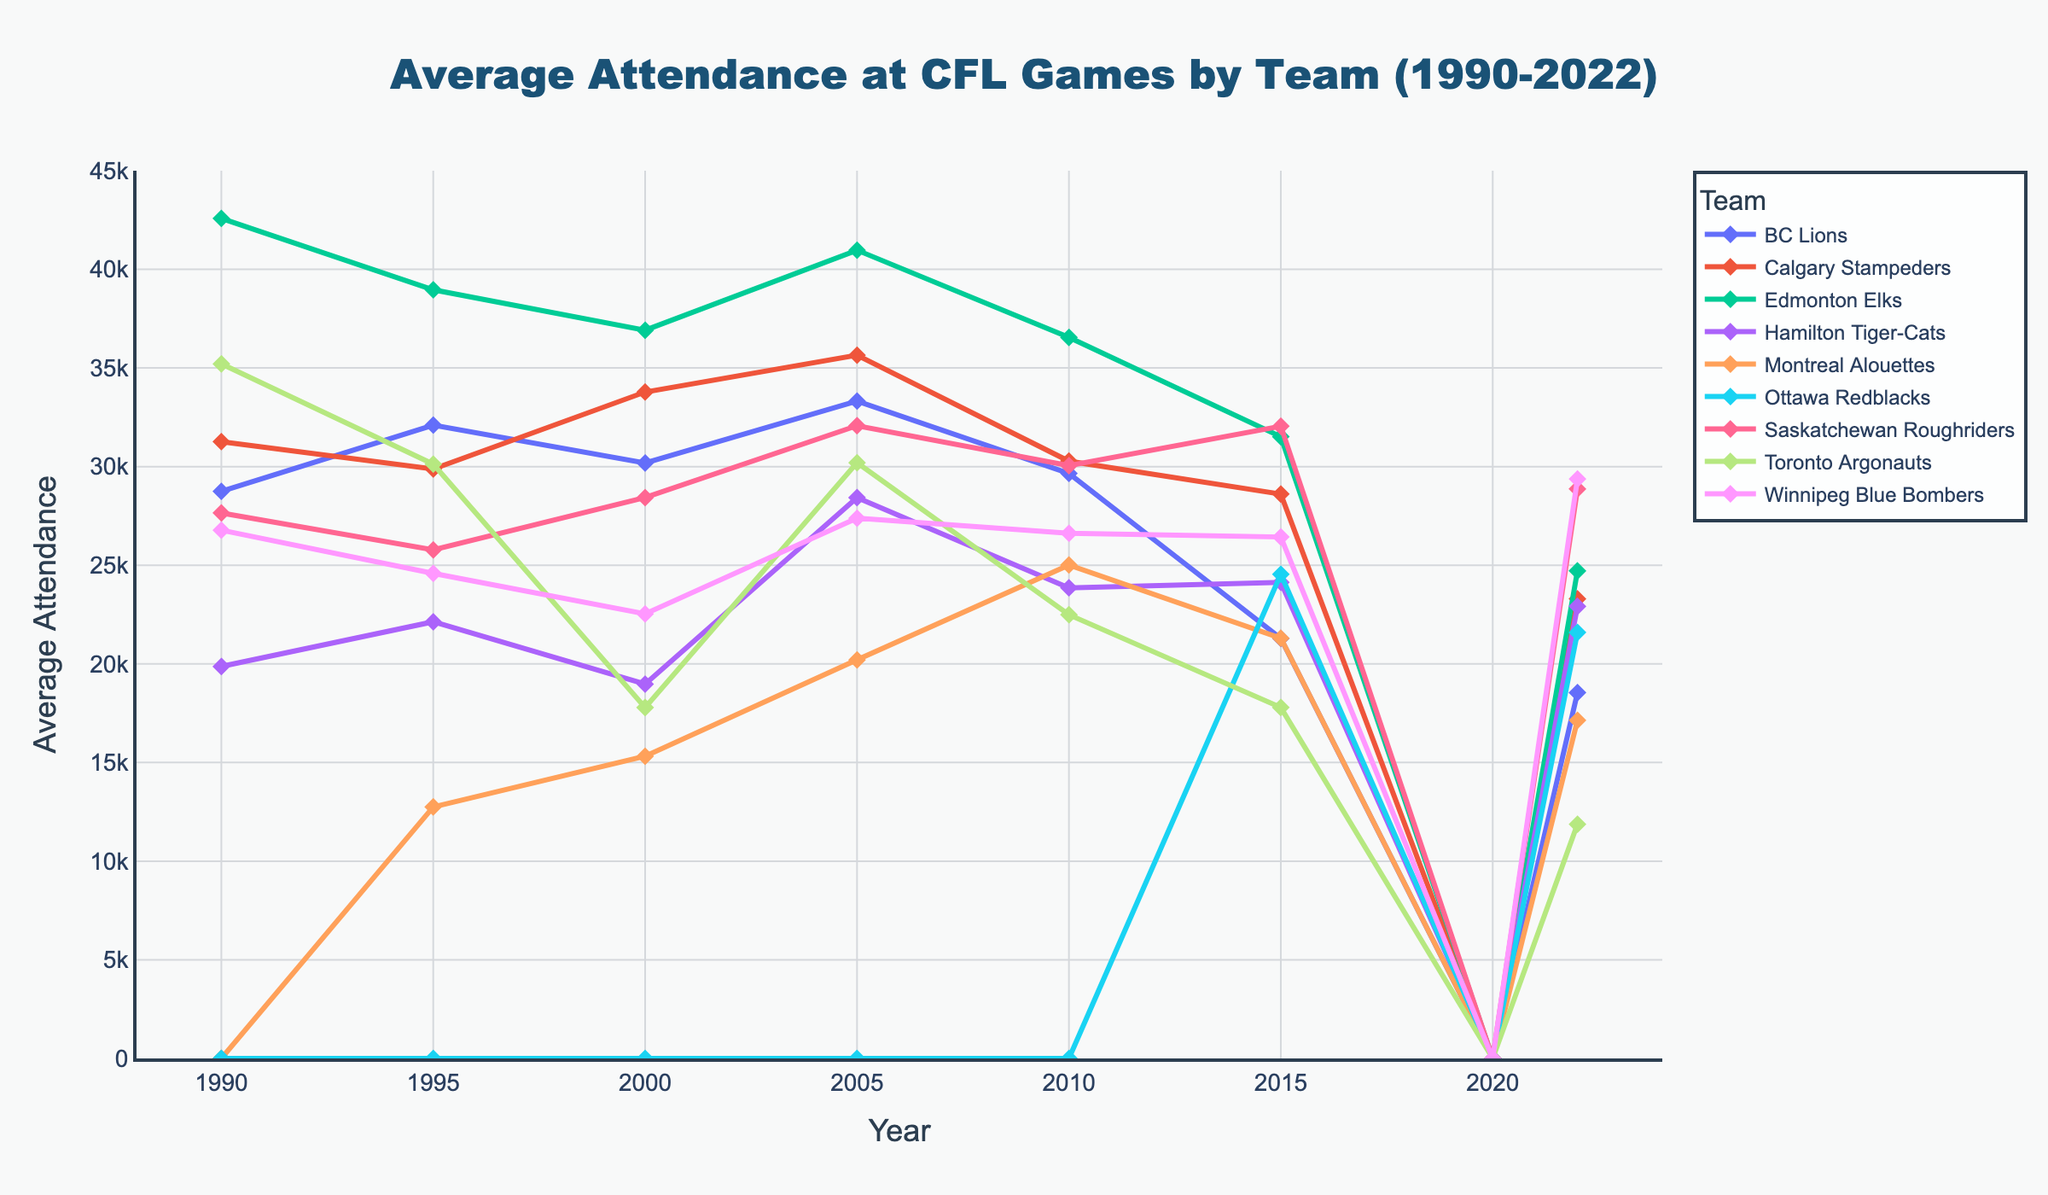Which team had the highest average attendance in 1990? Look at the attendance values for each team in 1990 and identify the highest one. Edmonton Elks had an attendance of 42,580, which is the highest.
Answer: Edmonton Elks Which team had the lowest average attendance in 2022? Examine the attendance values for each team in 2022. The Toronto Argonauts had the lowest attendance at 11,875.
Answer: Toronto Argonauts What is the difference in average attendance between the BC Lions and the Calgary Stampeders in 2005? Identify the attendance for both BC Lions (33,321) and Calgary Stampeders (35,650) in 2005. Calculate the difference: 35,650 - 33,321 = 2,329.
Answer: 2,329 How did the average attendance for the Hamilton Tiger-Cats change from 2000 to 2005? Compare the attendance figures for Hamilton Tiger-Cats in 2000 (18,975) and in 2005 (28,430). The change is calculated as 28,430 - 18,975 = 9,455.
Answer: Increased by 9,455 Which team's average attendance showed the most significant drop from 2010 to 2015? Compare the changes in average attendance for all teams between 2010 and 2015. The BC Lions had the most significant drop, decreasing from 29,658 to 21,290, which is a drop of 8,368.
Answer: BC Lions How did the average attendance for the Montreal Alouettes change from 1995 to 2010? Examine the attendance values for the Montreal Alouettes in 1995 (12,750) and 2010 (25,012). The difference is calculated as 25,012 - 12,750 = 12,262.
Answer: Increased by 12,262 Which team had no recorded attendance in 1990? Look for teams with an attendance of 0 in 1990. The Montreal Alouettes did not have recorded attendance data for that year.
Answer: Montreal Alouettes What was the average attendance of Ottawa Redblacks in 2022? Identify the attendance value for Ottawa Redblacks in 2022, which is 21,593. Since there is only one value, the average is the same.
Answer: 21,593 Which team had the highest average attendance in 2020? Since COVID-19 led to the cancellation of the 2020 CFL season, the attendance for all teams in 2020 is 0.
Answer: No team What is the range of average attendance values for the Winnipeg Blue Bombers from 1990 to 2022? Identify the minimum and maximum attendance values for Winnipeg Blue Bombers between 1990 and 2022. The minimum is 22,535 (in 2000) and the maximum is 29,376 (in 2022). The range is calculated as 29,376 - 22,535 = 6,841.
Answer: 6,841 